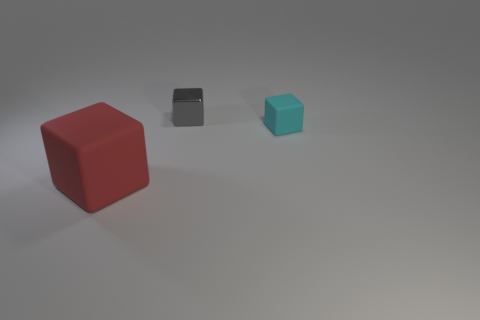Is the number of big matte blocks behind the gray metallic object greater than the number of red blocks behind the cyan rubber thing?
Your response must be concise. No. Are there any other things that are the same size as the red thing?
Give a very brief answer. No. How many blocks are big blue shiny things or gray things?
Give a very brief answer. 1. How many things are objects that are behind the tiny matte object or small yellow matte cubes?
Your response must be concise. 1. There is a rubber object that is behind the big red thing on the left side of the matte block behind the big object; what is its shape?
Offer a terse response. Cube. What number of tiny gray metallic objects have the same shape as the tiny cyan rubber thing?
Your response must be concise. 1. Is the material of the tiny cyan cube the same as the small gray block?
Your response must be concise. No. How many metallic objects are to the right of the thing on the right side of the tiny thing that is on the left side of the small cyan block?
Keep it short and to the point. 0. Are there any other cyan cubes that have the same material as the cyan cube?
Make the answer very short. No. Are there fewer large shiny cubes than tiny gray metal objects?
Ensure brevity in your answer.  Yes. 